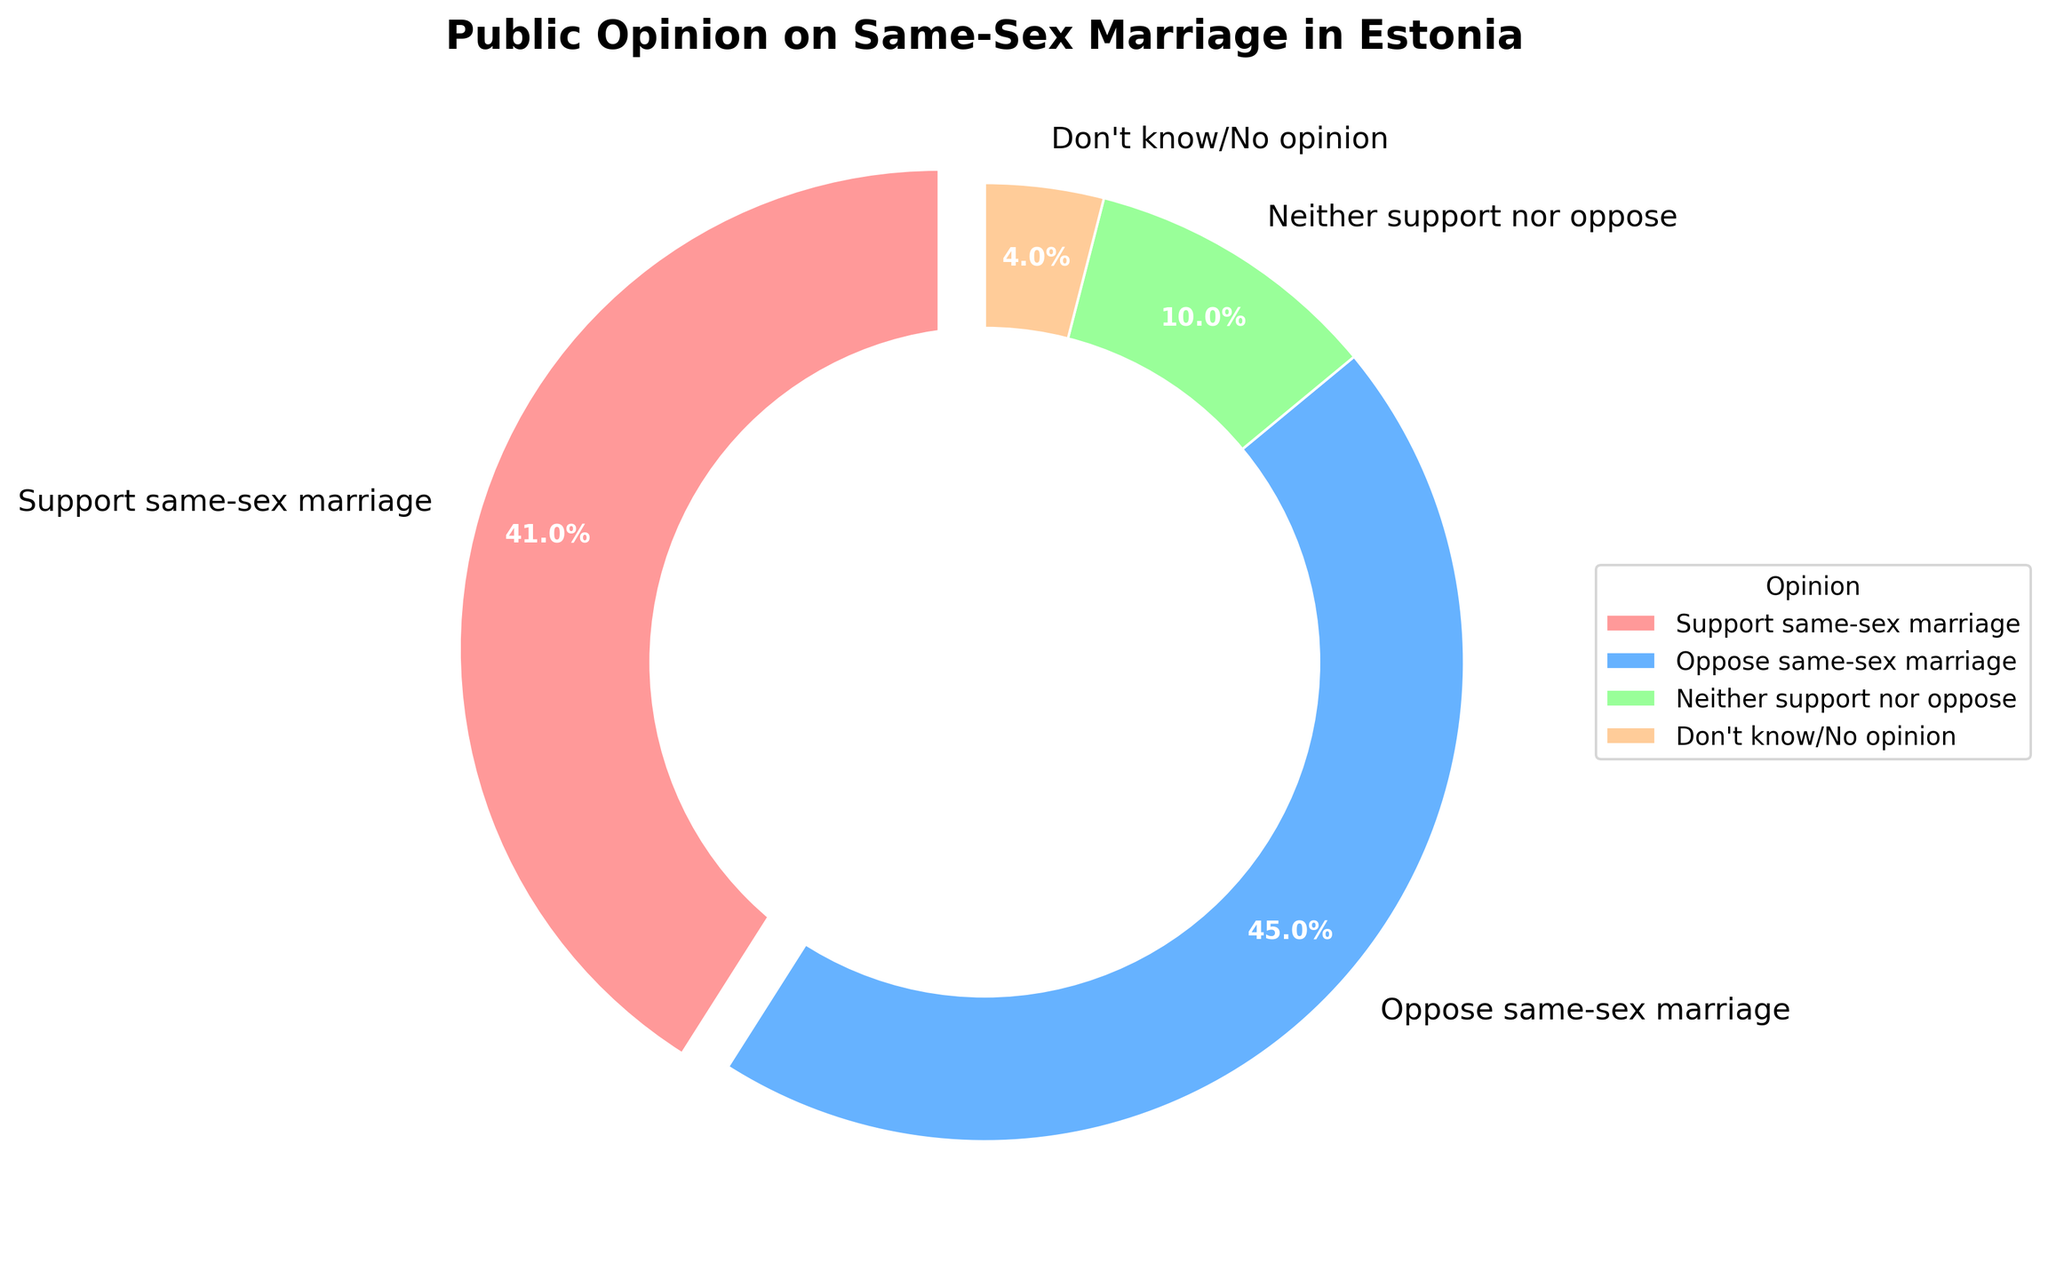What percentage of people support same-sex marriage? The figure indicates the proportion of opinions. According to the pie chart, the "Support same-sex marriage" section is shown as 41%.
Answer: 41% Which opinion has the highest percentage? By comparing the sizes of the pie segments, "Oppose same-sex marriage" appears to be the largest, at 45%.
Answer: Oppose same-sex marriage How many percentage points more oppose same-sex marriage compared to those who support it? "Oppose same-sex marriage" is 45%, and "Support same-sex marriage" is 41%. The difference is 45% - 41% = 4%.
Answer: 4% What percentage of people neither support nor oppose same-sex marriage? The chart segment for "Neither support nor oppose" is indicated as 10%.
Answer: 10% Among the given opinions, which one has the smallest percentage, and what is it? Observing the pie chart, the smallest segment is "Don't know/No opinion," representing 4%.
Answer: Don't know/No opinion, 4% Is the percentage of people who don't know or have no opinion equal to those who neither support nor oppose? The percentage for "Don't know/No opinion" is 4%, while for "Neither support nor oppose" it is 10%. These values are not equal.
Answer: No Does the combined percentage of "Support same-sex marriage" and "Neither support nor oppose" exceed the percentage of "Oppose same-sex marriage"? Summing "Support same-sex marriage" (41%) and "Neither support nor oppose" (10%) gives 51%. This is greater than the 45% for "Oppose same-sex marriage".
Answer: Yes What is the combined percentage of those who either oppose or have no opinion on same-sex marriage? Combining "Oppose same-sex marriage" (45%) and "Don't know/No opinion" (4%) results in 49%.
Answer: 49% Which color represents the "Support same-sex marriage" opinion? The segment for "Support same-sex marriage" is visually represented by the red shade.
Answer: Red What is the title of the pie chart? The title is displayed at the top of the chart. It reads, "Public Opinion on Same-Sex Marriage in Estonia".
Answer: Public Opinion on Same-Sex Marriage in Estonia 